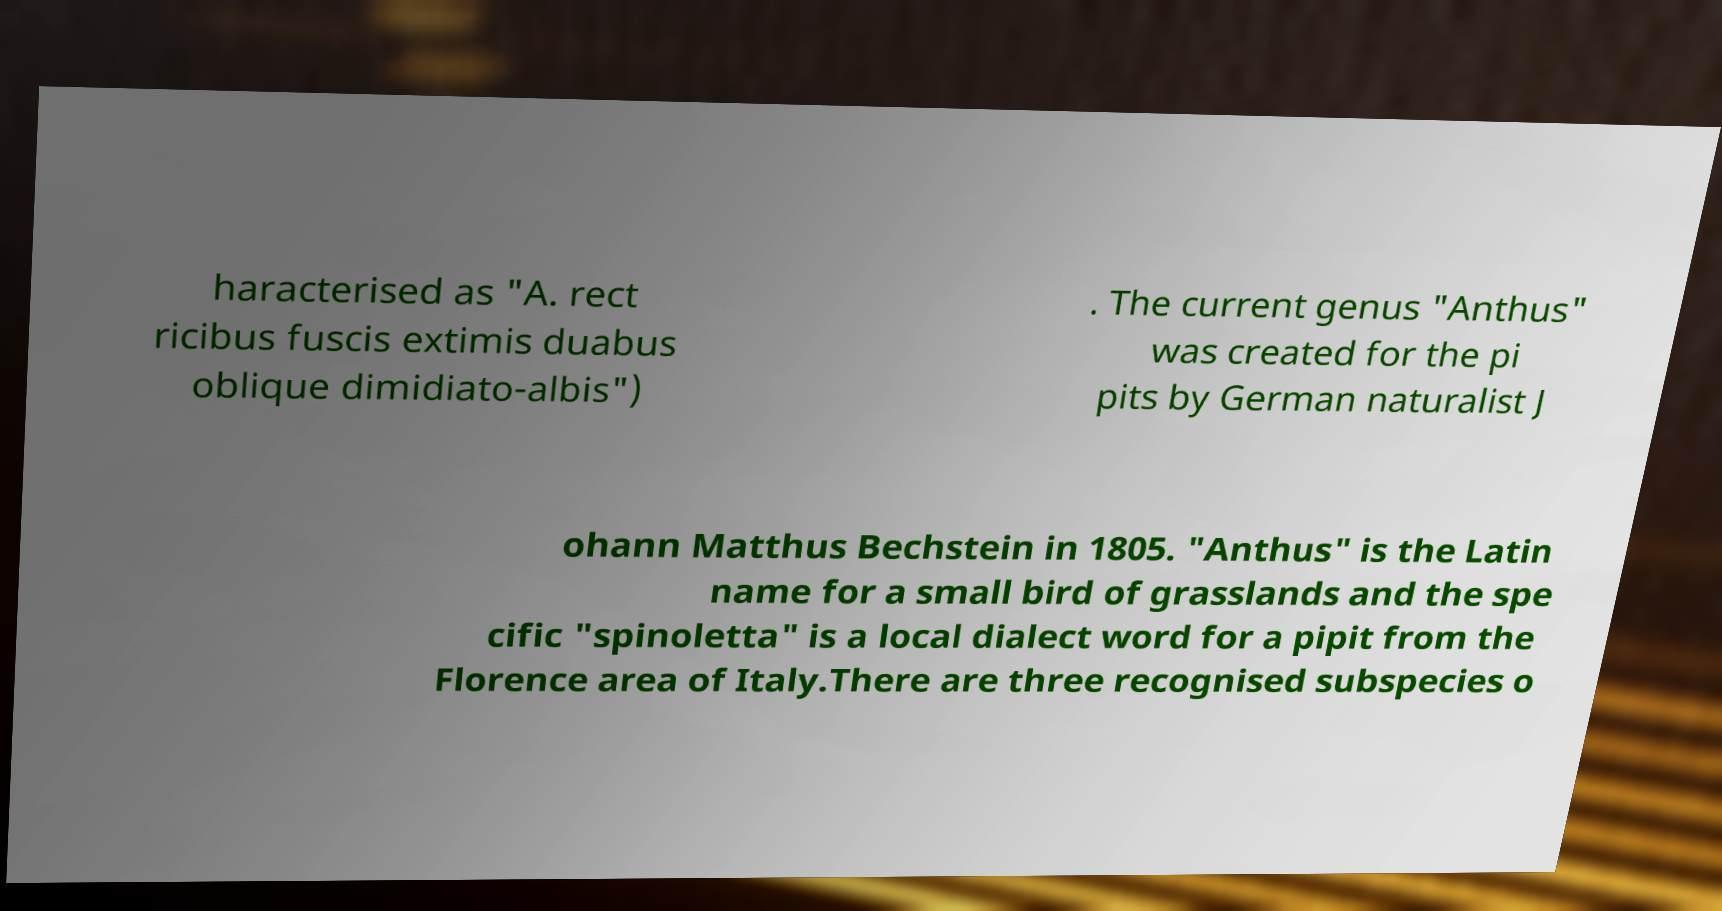There's text embedded in this image that I need extracted. Can you transcribe it verbatim? haracterised as "A. rect ricibus fuscis extimis duabus oblique dimidiato-albis") . The current genus "Anthus" was created for the pi pits by German naturalist J ohann Matthus Bechstein in 1805. "Anthus" is the Latin name for a small bird of grasslands and the spe cific "spinoletta" is a local dialect word for a pipit from the Florence area of Italy.There are three recognised subspecies o 